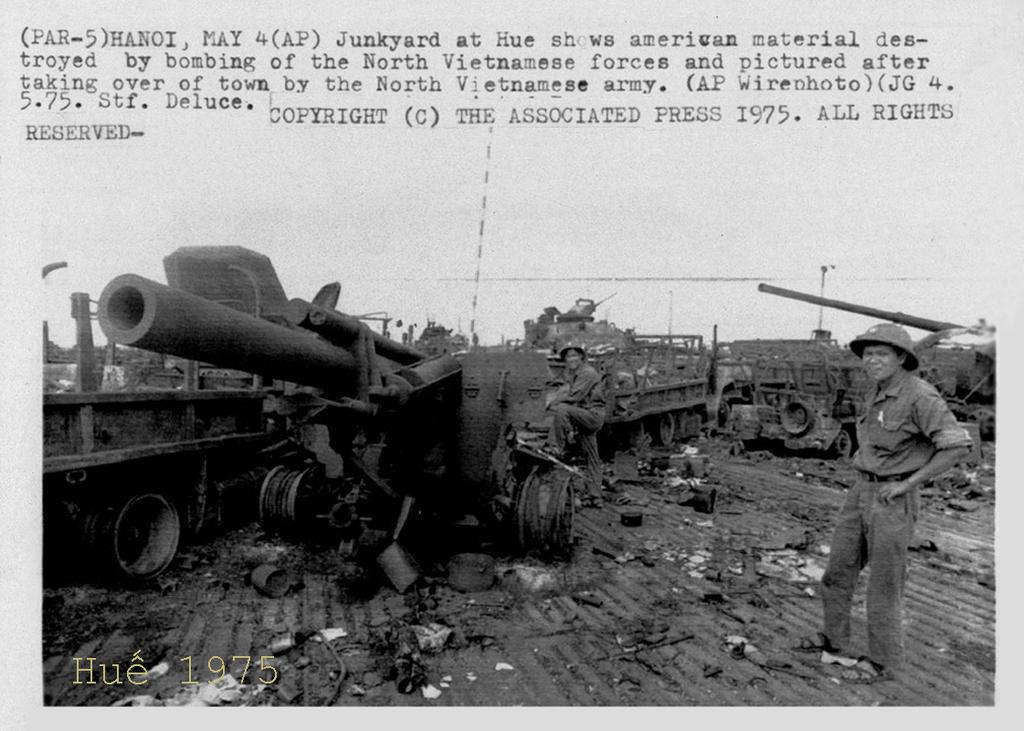<image>
Render a clear and concise summary of the photo. A battlefield with two soldiers standing in the wreckage of a train with the date 1975. 